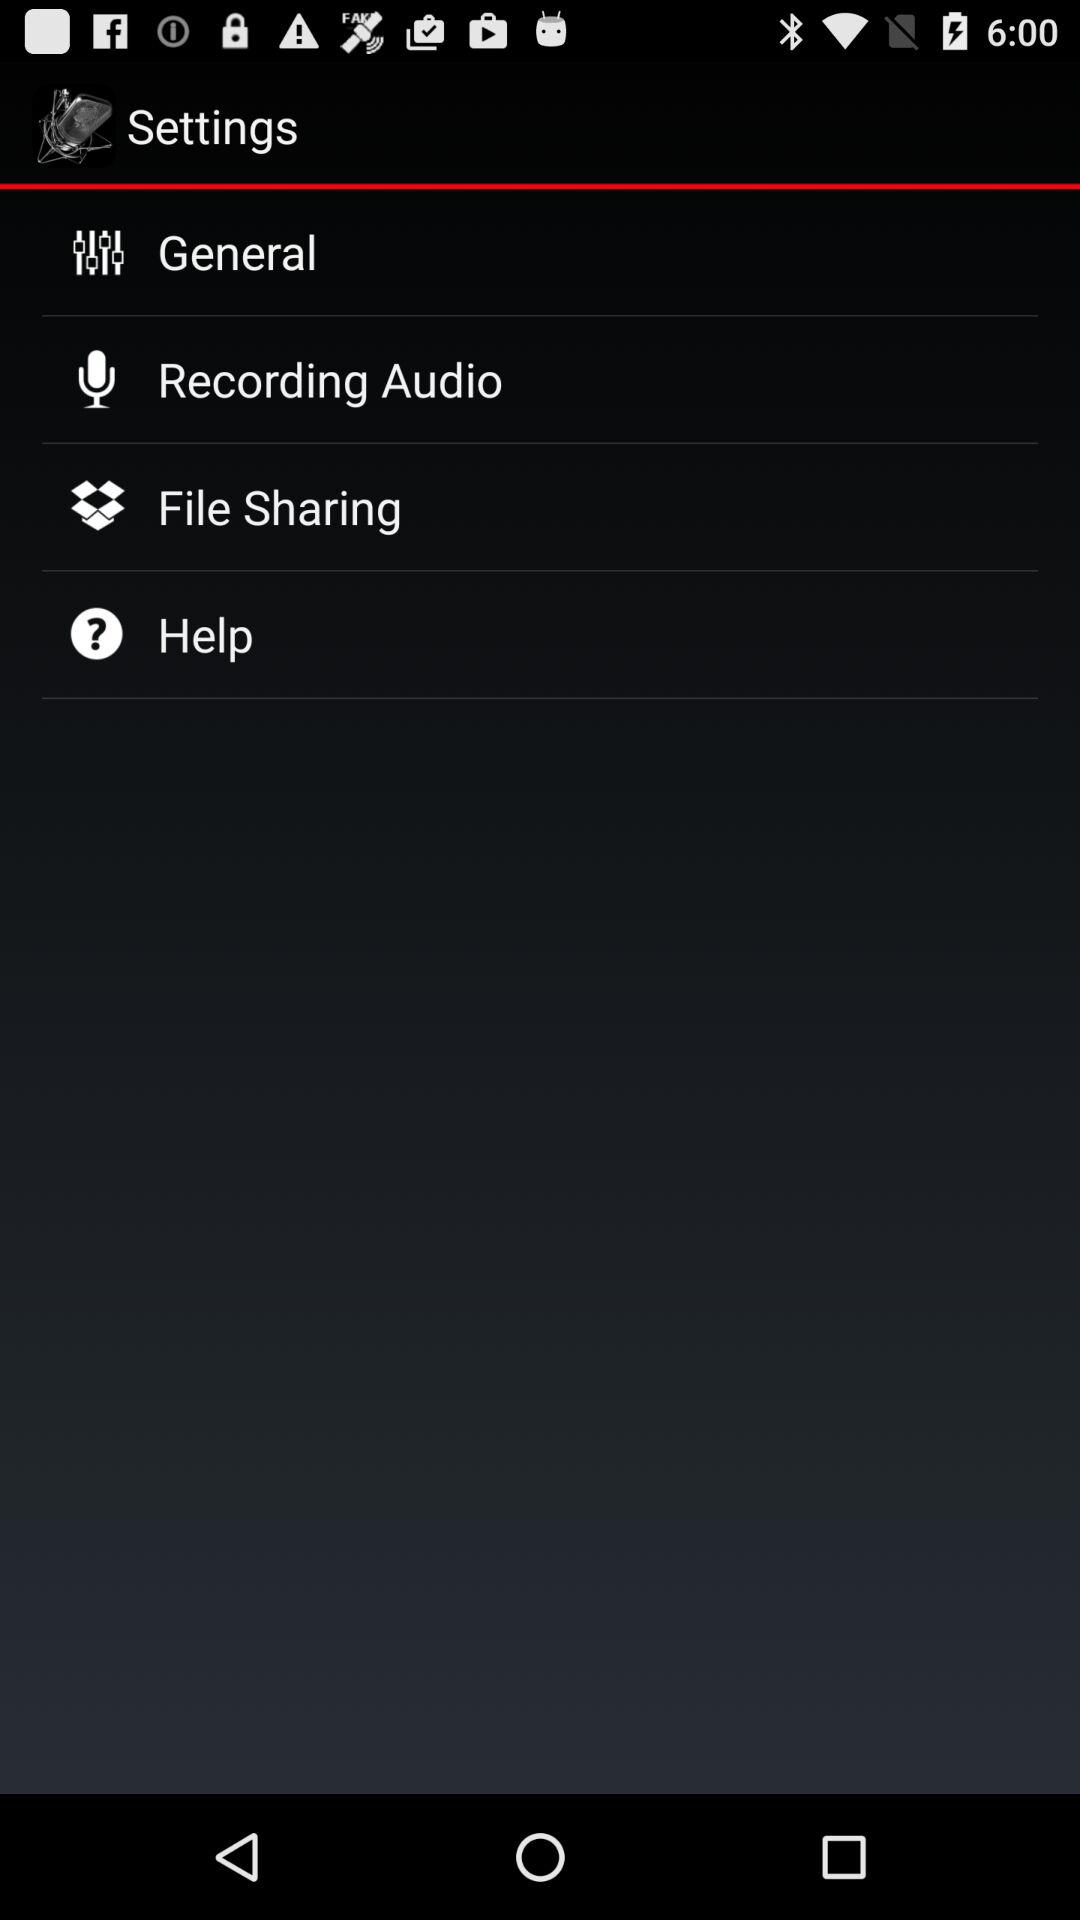How many items are in the settings menu?
Answer the question using a single word or phrase. 4 